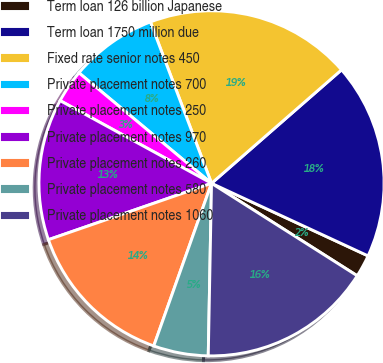Convert chart to OTSL. <chart><loc_0><loc_0><loc_500><loc_500><pie_chart><fcel>Term loan 126 billion Japanese<fcel>Term loan 1750 million due<fcel>Fixed rate senior notes 450<fcel>Private placement notes 700<fcel>Private placement notes 250<fcel>Private placement notes 970<fcel>Private placement notes 260<fcel>Private placement notes 580<fcel>Private placement notes 1060<nl><fcel>2.09%<fcel>18.33%<fcel>19.34%<fcel>8.18%<fcel>3.1%<fcel>13.25%<fcel>14.27%<fcel>5.13%<fcel>16.3%<nl></chart> 